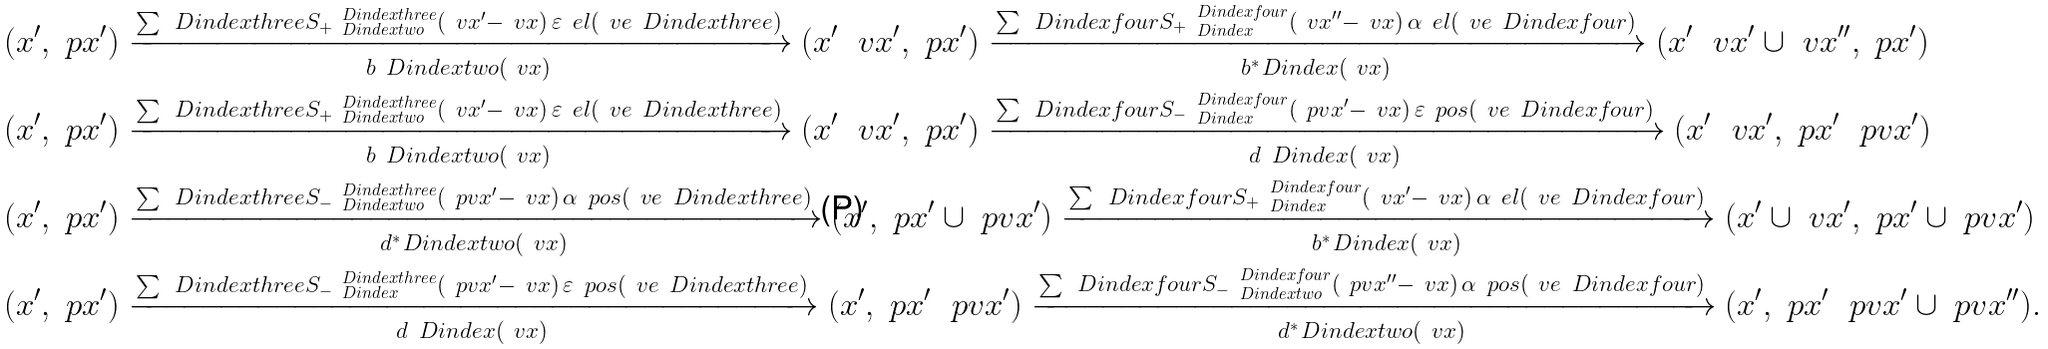<formula> <loc_0><loc_0><loc_500><loc_500>( x ^ { \prime } , \ p x ^ { \prime } ) & \xrightarrow [ b _ { \ } D i n d e x t w o ( \ v x ) ] { \sum _ { \ } D i n d e x t h r e e { S _ { + } } ^ { \ D i n d e x t h r e e } _ { \ D i n d e x t w o } ( \ v x ^ { \prime } - \ v x ) \, \varepsilon _ { \ } e l ( \ v e _ { \ } D i n d e x t h r e e ) } ( x ^ { \prime } \ \ v x ^ { \prime } , \ p x ^ { \prime } ) \xrightarrow [ b ^ { * } _ { \ } D i n d e x ( \ v x ) ] { \sum _ { \ } D i n d e x f o u r { S _ { + } } ^ { \ D i n d e x f o u r } _ { \ D i n d e x } ( \ v x ^ { \prime \prime } - \ v x ) \, \alpha _ { \ } e l ( \ v e _ { \ } D i n d e x f o u r ) } ( x ^ { \prime } \ \ v x ^ { \prime } \cup \ v x ^ { \prime \prime } , \ p x ^ { \prime } ) \\ ( x ^ { \prime } , \ p x ^ { \prime } ) & \xrightarrow [ b _ { \ } D i n d e x t w o ( \ v x ) ] { \sum _ { \ } D i n d e x t h r e e { S _ { + } } ^ { \ D i n d e x t h r e e } _ { \ D i n d e x t w o } ( \ v x ^ { \prime } - \ v x ) \, \varepsilon _ { \ } e l ( \ v e _ { \ } D i n d e x t h r e e ) } ( x ^ { \prime } \ \ v x ^ { \prime } , \ p x ^ { \prime } ) \xrightarrow [ d _ { \ } D i n d e x ( \ v x ) ] { \sum _ { \ } D i n d e x f o u r { S _ { - } } ^ { \ D i n d e x f o u r } _ { \ D i n d e x } ( \ p v x ^ { \prime } - \ v x ) \, \varepsilon _ { \ } p o s ( \ v e _ { \ } D i n d e x f o u r ) } ( x ^ { \prime } \ \ v x ^ { \prime } , \ p x ^ { \prime } \ \ p v x ^ { \prime } ) \\ ( x ^ { \prime } , \ p x ^ { \prime } ) & \xrightarrow [ d ^ { * } _ { \ } D i n d e x t w o ( \ v x ) ] { \sum _ { \ } D i n d e x t h r e e { S _ { - } } ^ { \ D i n d e x t h r e e } _ { \ D i n d e x t w o } ( \ p v x ^ { \prime } - \ v x ) \, \alpha _ { \ } p o s ( \ v e _ { \ } D i n d e x t h r e e ) } ( x ^ { \prime } , \ p x ^ { \prime } \cup \ p v x ^ { \prime } ) \xrightarrow [ b ^ { * } _ { \ } D i n d e x ( \ v x ) ] { \sum _ { \ } D i n d e x f o u r { S _ { + } } ^ { \ D i n d e x f o u r } _ { \ D i n d e x } ( \ v x ^ { \prime } - \ v x ) \, \alpha _ { \ } e l ( \ v e _ { \ } D i n d e x f o u r ) } ( x ^ { \prime } \cup \ v x ^ { \prime } , \ p x ^ { \prime } \cup \ p v x ^ { \prime } ) \\ ( x ^ { \prime } , \ p x ^ { \prime } ) & \xrightarrow [ d _ { \ } D i n d e x ( \ v x ) ] { \sum _ { \ } D i n d e x t h r e e { S _ { - } } ^ { \ D i n d e x t h r e e } _ { \ D i n d e x } ( \ p v x ^ { \prime } - \ v x ) \, \varepsilon _ { \ } p o s ( \ v e _ { \ } D i n d e x t h r e e ) } ( x ^ { \prime } , \ p x ^ { \prime } \ \ p v x ^ { \prime } ) \xrightarrow [ d ^ { * } _ { \ } D i n d e x t w o ( \ v x ) ] { \sum _ { \ } D i n d e x f o u r { S _ { - } } ^ { \ D i n d e x f o u r } _ { \ D i n d e x t w o } ( \ p v x ^ { \prime \prime } - \ v x ) \, \alpha _ { \ } p o s ( \ v e _ { \ } D i n d e x f o u r ) } ( x ^ { \prime } , \ p x ^ { \prime } \ \ p v x ^ { \prime } \cup \ p v x ^ { \prime \prime } ) .</formula> 